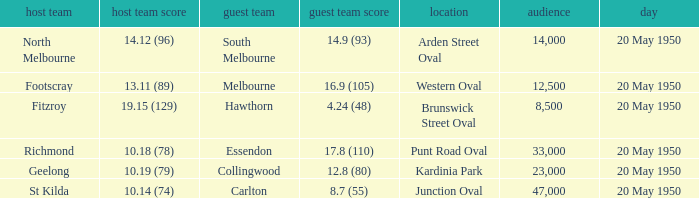Which team was the away team when the game was at punt road oval? Essendon. 